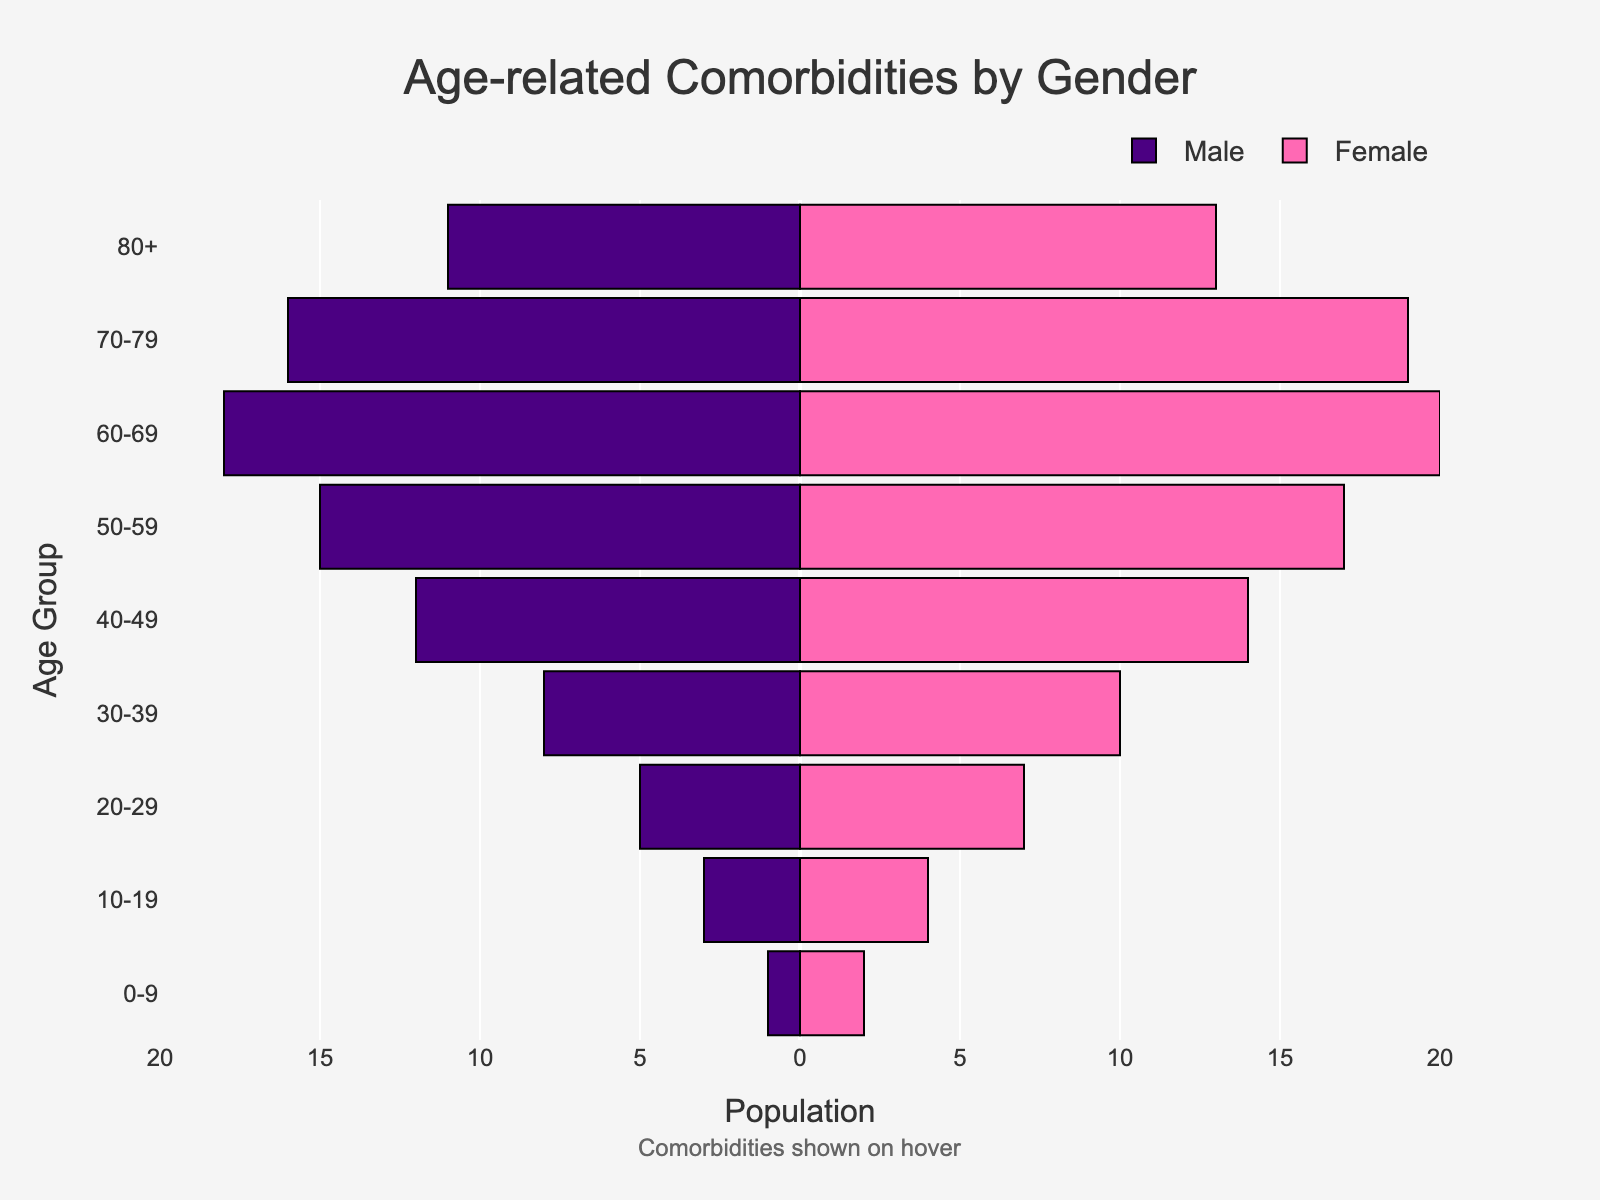What is the title of the plot? The title is located at the top center of the plot, it reads "Age-related Comorbidities by Gender".
Answer: Age-related Comorbidities by Gender Which age group has the highest number of male patients? Inspect the bar lengths on the left side. The age group 60-69 has the longest bar, indicating the highest number of male patients.
Answer: 60-69 What comorbidity is associated with the 30-39 age group? Hovering over the 30-39 age group bars reveals the comorbidity, which is Hypertension.
Answer: Hypertension How many female patients are in the 80+ age group? Look at the length of the bar for females in the 80+ age group on the right side. It corresponds to 13.
Answer: 13 How does the number of male patients in the 40-49 age group compare to female patients? The length of the 40-49 bars indicates the number. There are 12 males and 14 females, meaning there are 2 more female patients than male patients.
Answer: More females by 2 Which gender has more patients with Alzheimer's Disease, and how many more are there? Alzheimer's Disease is associated with the 80+ age group. Inspecting the bars, there are 13 female and 11 male patients, so there are 2 more female patients.
Answer: Female by 2 What is the total number of patients in the 50-59 age group? Add the number of male and female patients in the 50-59 age group: 15 males + 17 females = 32.
Answer: 32 What color represents female patients in the plot? Inspecting the bars, the color representing female patients is pink.
Answer: Pink Which age group shows a higher prevalence of Osteoarthritis among the genders, and by how much? Osteoarthritis is linked with the 50-59 age group. Comparing bar lengths, females (17) outnumber males (15) by 2.
Answer: Females by 2 Identify the age group with the lowest number of total patients. Summing up the patients in each age group and comparing, 0-9 has the fewest total (1 male + 2 female = 3).
Answer: 0-9 